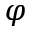Convert formula to latex. <formula><loc_0><loc_0><loc_500><loc_500>\varphi</formula> 